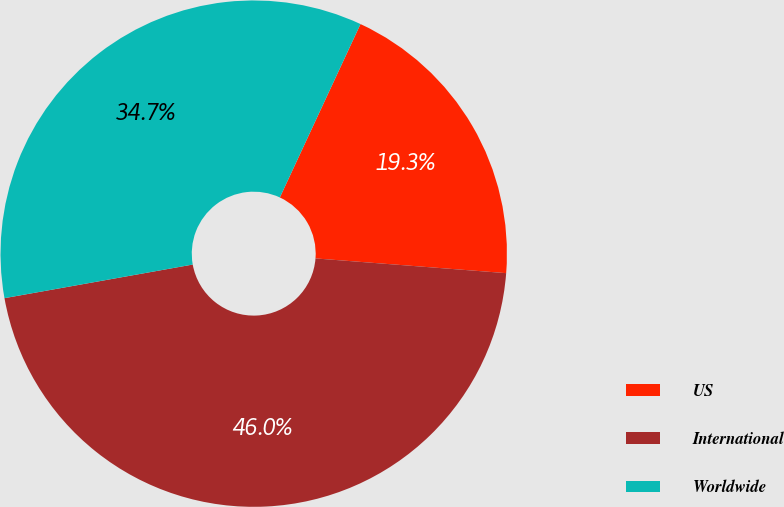Convert chart to OTSL. <chart><loc_0><loc_0><loc_500><loc_500><pie_chart><fcel>US<fcel>International<fcel>Worldwide<nl><fcel>19.3%<fcel>45.96%<fcel>34.74%<nl></chart> 